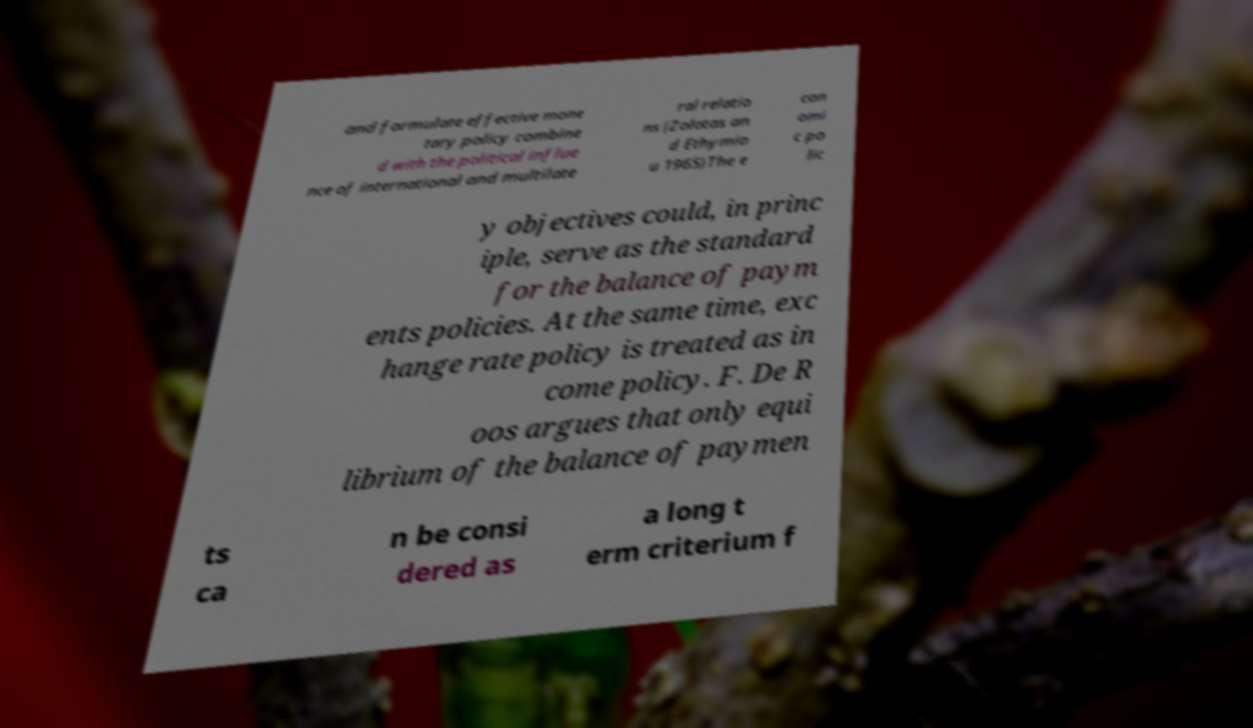For documentation purposes, I need the text within this image transcribed. Could you provide that? and formulate effective mone tary policy combine d with the political influe nce of international and multilate ral relatio ns (Zolotas an d Ethymio u 1965)The e con omi c po lic y objectives could, in princ iple, serve as the standard for the balance of paym ents policies. At the same time, exc hange rate policy is treated as in come policy. F. De R oos argues that only equi librium of the balance of paymen ts ca n be consi dered as a long t erm criterium f 